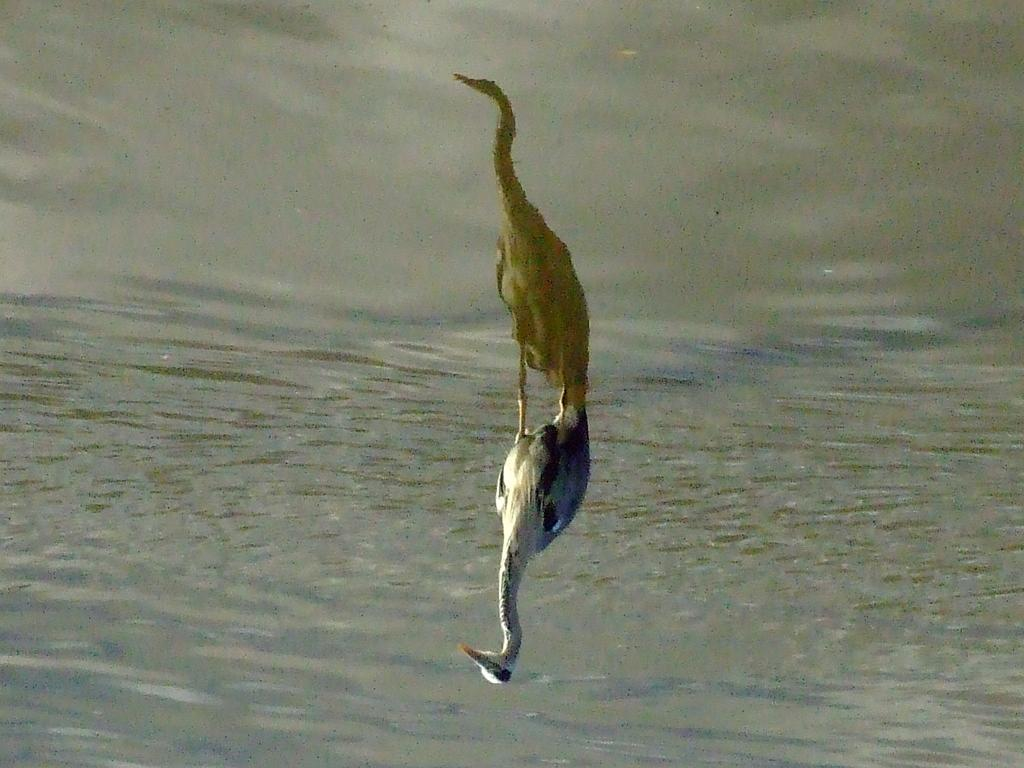What type of animals can be seen in the image? Birds can be seen in the image. What is the primary element in which the birds are situated? The birds are situated in water. What color is the sky in the image? There is no sky visible in the image; it only shows birds in water. 